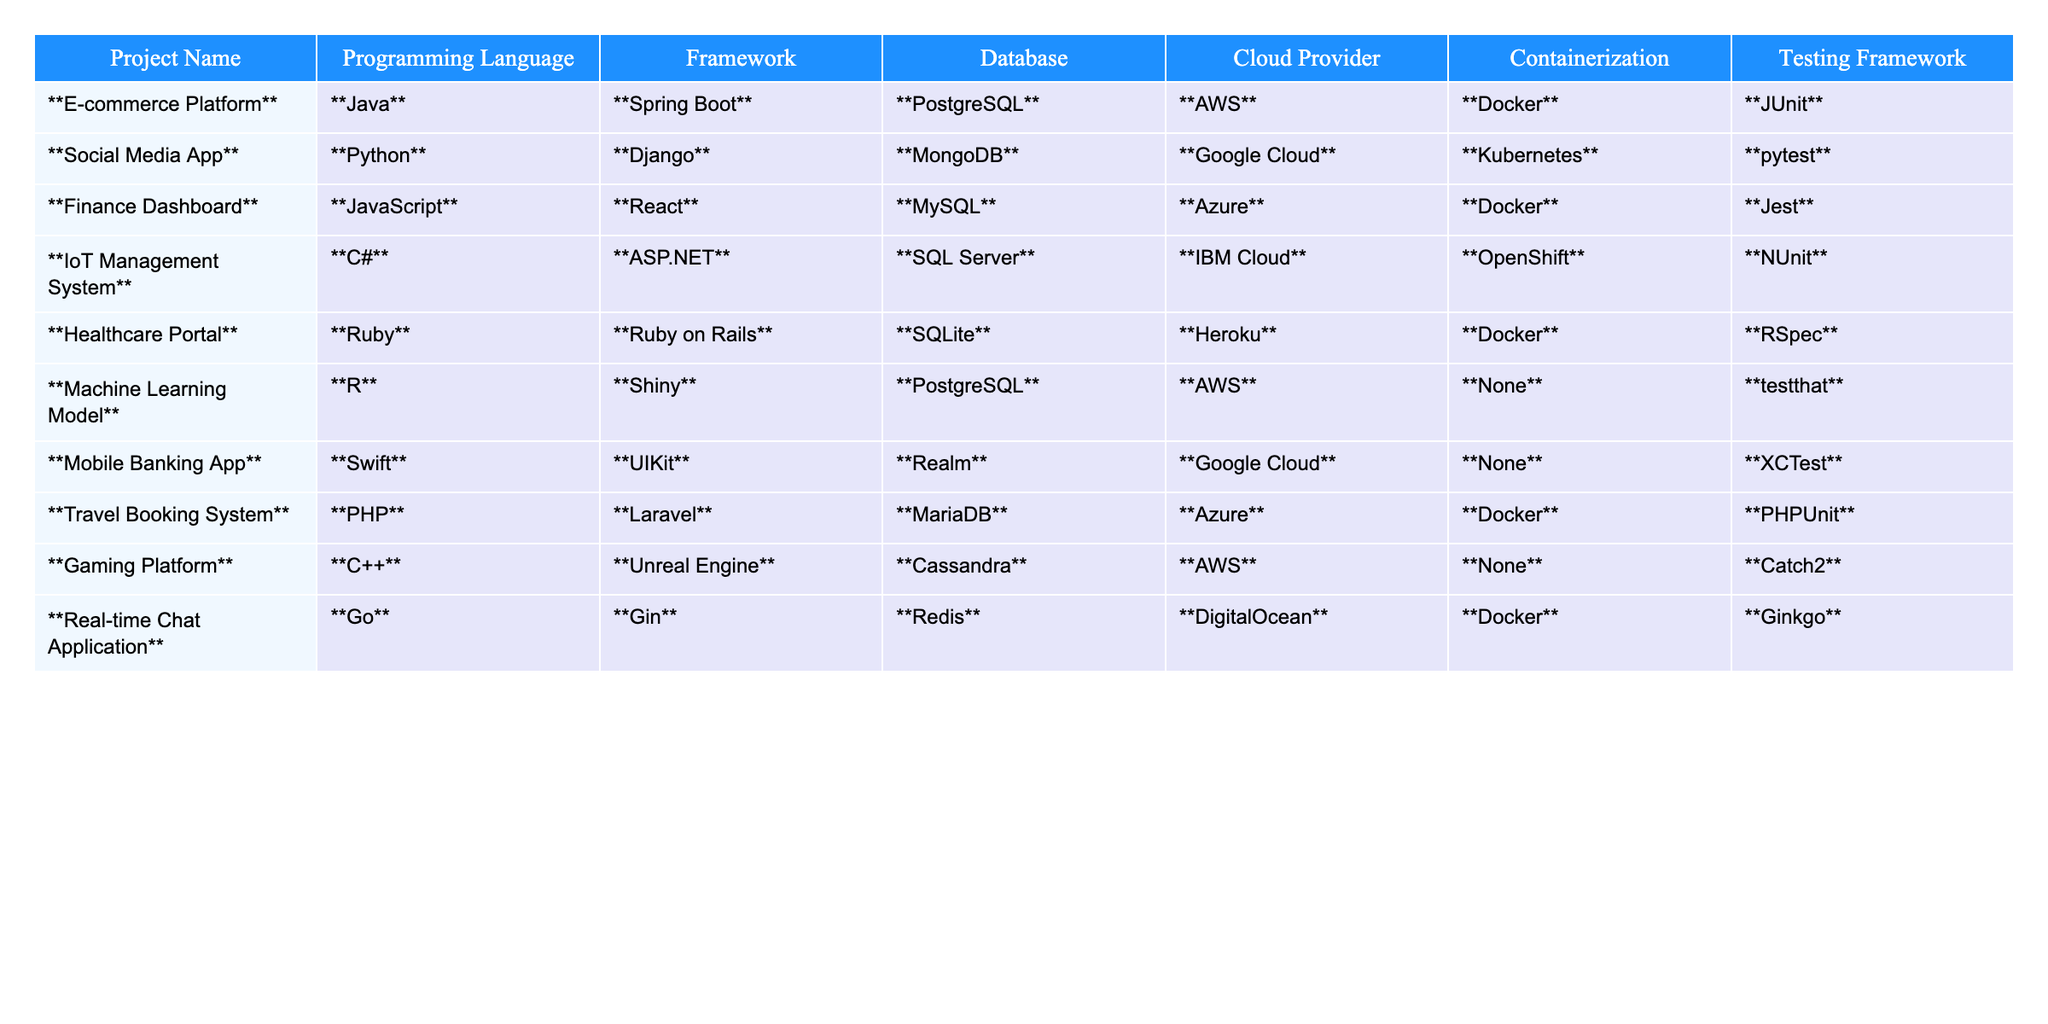What programming language is used in the E-commerce Platform? The E-commerce Platform is listed in the table under the Programming Language column. The corresponding value for this project is Java.
Answer: Java How many projects use Docker for containerization? By examining the Containerization column, I can count the projects that specify Docker. The projects using Docker are the E-commerce Platform, Finance Dashboard, Healthcare Portal, Travel Booking System, Real-time Chat Application, totaling 5 projects.
Answer: 5 Which database is used in the Gaming Platform? Looking at the Gaming Platform row under the Database column, the corresponding database is Cassandra.
Answer: Cassandra Are there any projects that use Google Cloud as the cloud provider? I can scan through the Cloud Provider column for the value Google Cloud. The Social Media App and Mobile Banking App both use Google Cloud, confirming that there are projects with this provider.
Answer: Yes Which programming language is most commonly used? To find the most commonly used programming language, I can count the occurrences of each language in the Programming Language column. Java appears once, Python once, and so on. The most frequent is Java, used in 2 projects: E-commerce Platform and Finance Dashboard.
Answer: Java How many projects use SQL Server as their database? I check the Database column for the value SQL Server. In the table, it corresponds to the IoT Management System, which means it is used in only one project.
Answer: 1 Which projects use PostgreSQL as the database? By going through the Database column, I find that both the E-commerce Platform and the Machine Learning Model use PostgreSQL as their database.
Answer: E-commerce Platform, Machine Learning Model What is the total number of projects listed in the table? I can count the total number of rows (excluding the header) in the table, which gives me 10 projects in total.
Answer: 10 How many unique cloud providers are represented in the projects? To determine the unique cloud providers, I can list the values in the Cloud Provider column, which are AWS, Google Cloud, Azure, IBM Cloud, Heroku, and DigitalOcean. This totals to 6 unique providers.
Answer: 6 Which project uses the least popular programming language? To determine the least popular language, I tally each language's occurrence from the Programming Language column. Based on the counts, R is the least common, appearing only once in the Machine Learning Model project.
Answer: R 